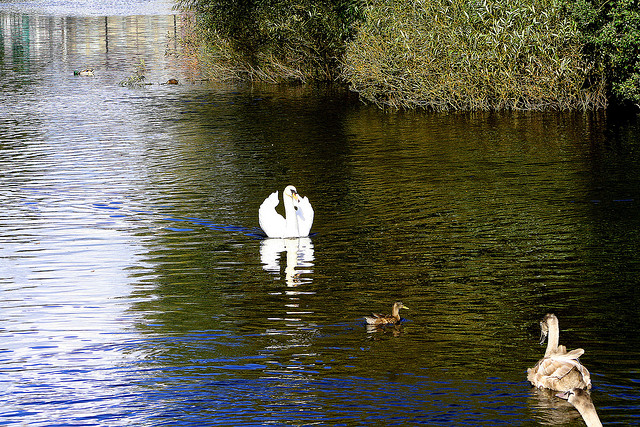What are the behaviors of swans and ducks when they are in such settings? In settings like the one depicted, both swans and ducks exhibit a range of behaviors significant to their species. Swans are often seen gliding majestically across the water, occasionally foraging for food beneath the surface. Ducks, being more social and agile, can be seen dabbling near the water's edge or in shallow water. Both species engage in preening to maintain their feathers, which helps with insulation and buoyancy. 